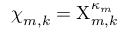Convert formula to latex. <formula><loc_0><loc_0><loc_500><loc_500>{ \chi } _ { m , k } = { \chi } _ { m , k } ^ { \kappa _ { m } }</formula> 